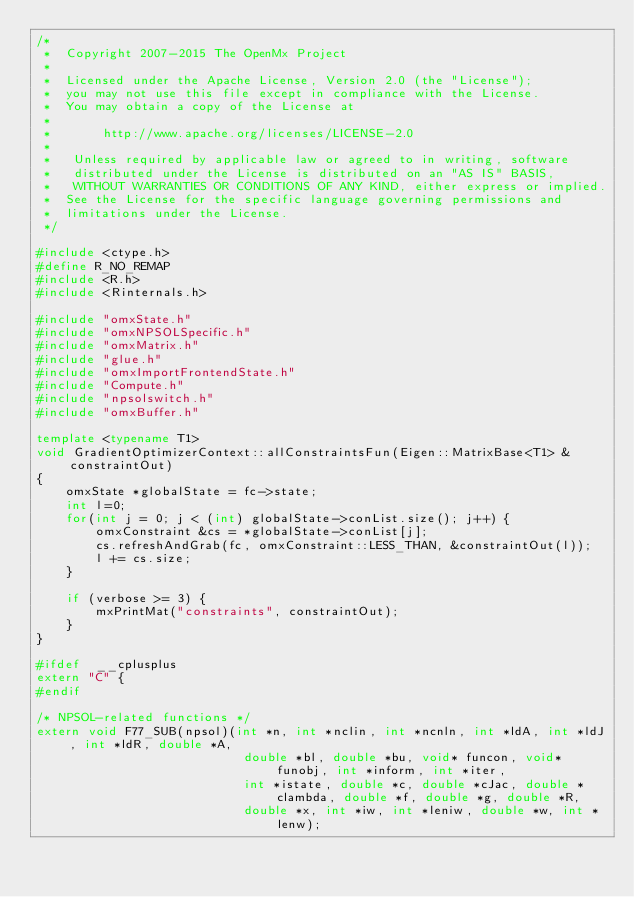<code> <loc_0><loc_0><loc_500><loc_500><_C++_>/*
 *  Copyright 2007-2015 The OpenMx Project
 *
 *  Licensed under the Apache License, Version 2.0 (the "License");
 *  you may not use this file except in compliance with the License.
 *  You may obtain a copy of the License at
 *
 *       http://www.apache.org/licenses/LICENSE-2.0
 *
 *   Unless required by applicable law or agreed to in writing, software
 *   distributed under the License is distributed on an "AS IS" BASIS,
 *   WITHOUT WARRANTIES OR CONDITIONS OF ANY KIND, either express or implied.
 *  See the License for the specific language governing permissions and
 *  limitations under the License.
 */

#include <ctype.h>
#define R_NO_REMAP
#include <R.h>
#include <Rinternals.h>

#include "omxState.h"
#include "omxNPSOLSpecific.h"
#include "omxMatrix.h"
#include "glue.h"
#include "omxImportFrontendState.h"
#include "Compute.h"
#include "npsolswitch.h"
#include "omxBuffer.h"

template <typename T1>
void GradientOptimizerContext::allConstraintsFun(Eigen::MatrixBase<T1> &constraintOut)
{
	omxState *globalState = fc->state;
	int l=0;
	for(int j = 0; j < (int) globalState->conList.size(); j++) {
		omxConstraint &cs = *globalState->conList[j];
		cs.refreshAndGrab(fc, omxConstraint::LESS_THAN, &constraintOut(l));
		l += cs.size;
	}

	if (verbose >= 3) {
		mxPrintMat("constraints", constraintOut);
	}
}

#ifdef  __cplusplus
extern "C" {
#endif

/* NPSOL-related functions */
extern void F77_SUB(npsol)(int *n, int *nclin, int *ncnln, int *ldA, int *ldJ, int *ldR, double *A,
                            double *bl, double *bu, void* funcon, void* funobj, int *inform, int *iter, 
                            int *istate, double *c, double *cJac, double *clambda, double *f, double *g, double *R,
                            double *x, int *iw, int *leniw, double *w, int *lenw);</code> 